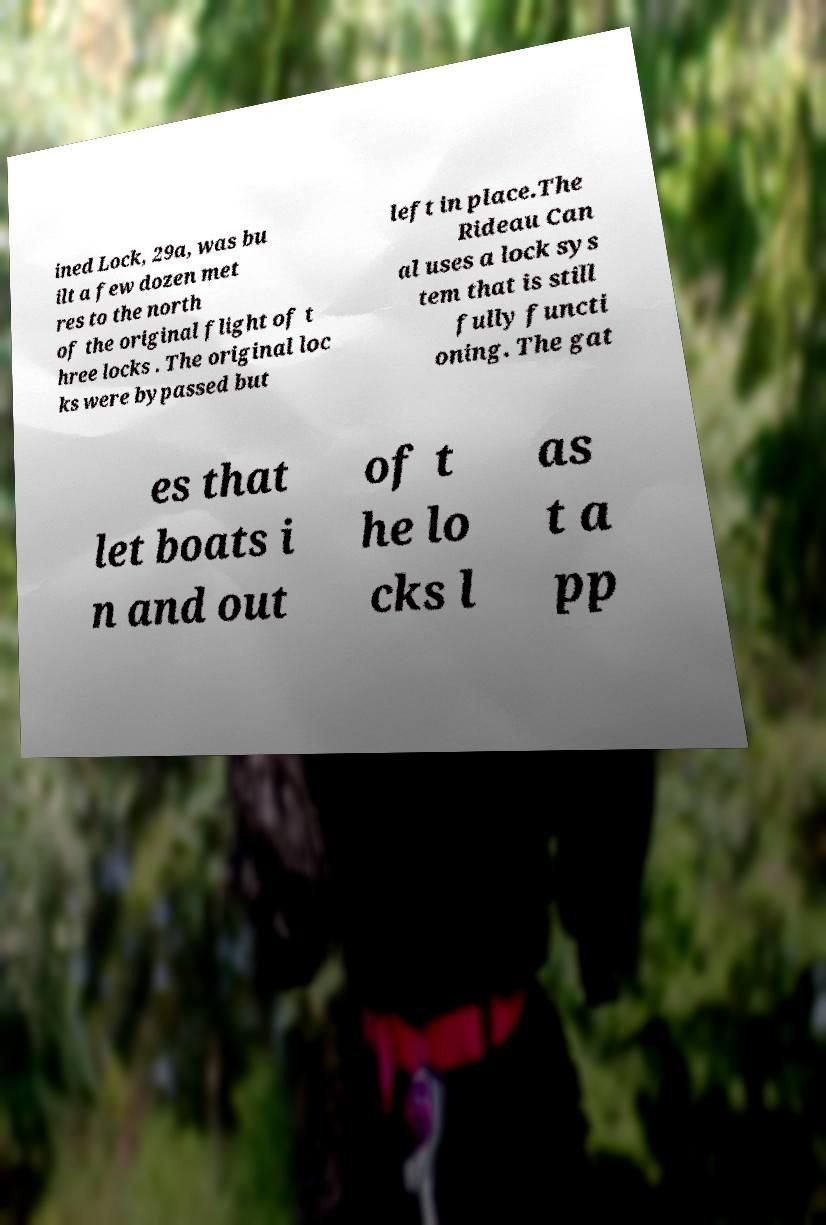Could you assist in decoding the text presented in this image and type it out clearly? ined Lock, 29a, was bu ilt a few dozen met res to the north of the original flight of t hree locks . The original loc ks were bypassed but left in place.The Rideau Can al uses a lock sys tem that is still fully functi oning. The gat es that let boats i n and out of t he lo cks l as t a pp 